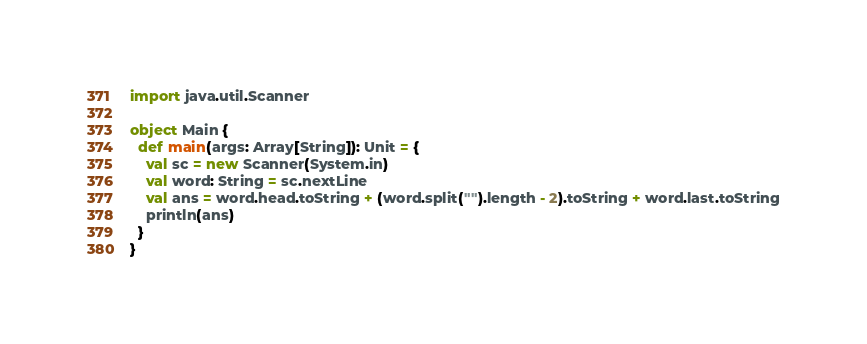<code> <loc_0><loc_0><loc_500><loc_500><_Scala_>import java.util.Scanner

object Main {
  def main(args: Array[String]): Unit = {
    val sc = new Scanner(System.in)
    val word: String = sc.nextLine
    val ans = word.head.toString + (word.split("").length - 2).toString + word.last.toString
    println(ans)
  }
}
</code> 